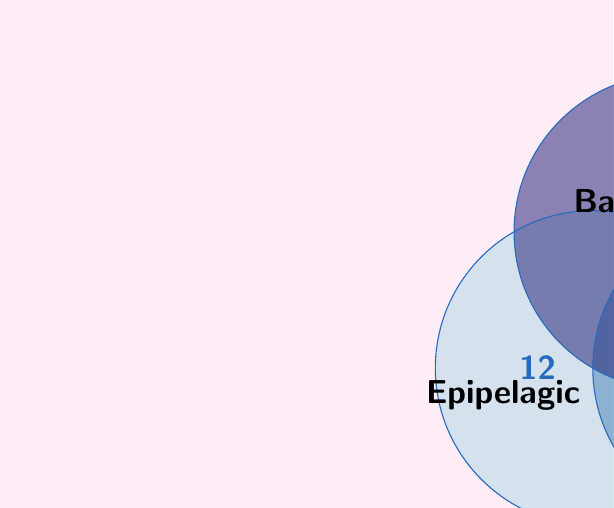Give your solution to this math problem. Let's approach this step-by-step:

1) First, we need to understand what the question is asking. We're looking for species that inhabit at least two zones, which means we need to find the sum of all intersections between two or more sets.

2) From the Venn diagram, we can see:
   - 5 species in Epipelagic ∩ Mesopelagic
   - 4 species in Mesopelagic ∩ Bathypelagic
   - 3 species in Epipelagic ∩ Bathypelagic
   - 2 species in Epipelagic ∩ Mesopelagic ∩ Bathypelagic

3) To find the total number of species in at least two zones, we need to add these numbers:

   $$(5 - 2) + (4 - 2) + (3 - 2) + 2 = 3 + 2 + 1 + 2 = 8$$

   We subtract 2 from each two-set intersection to avoid counting the species in the three-set intersection multiple times.

4) Therefore, the total number of species that inhabit at least two of these zones is 8.

This problem demonstrates the application of set theory in marine biology, specifically in understanding species distribution across different ocean zones.
Answer: 8 species 